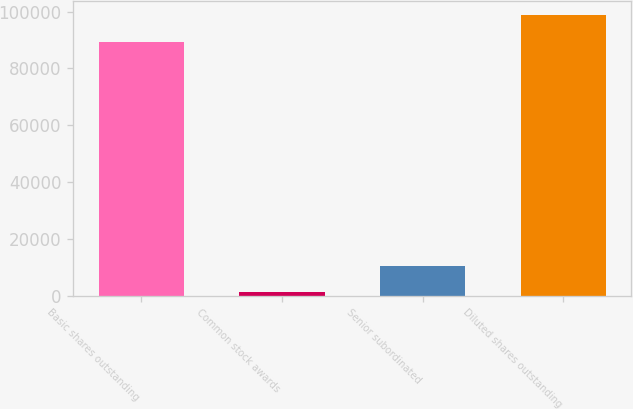Convert chart. <chart><loc_0><loc_0><loc_500><loc_500><bar_chart><fcel>Basic shares outstanding<fcel>Common stock awards<fcel>Senior subordinated<fcel>Diluted shares outstanding<nl><fcel>89468<fcel>1155<fcel>10409.4<fcel>98722.4<nl></chart> 